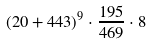Convert formula to latex. <formula><loc_0><loc_0><loc_500><loc_500>( 2 0 + 4 4 3 ) ^ { 9 } \cdot \frac { 1 9 5 } { 4 6 9 } \cdot 8</formula> 